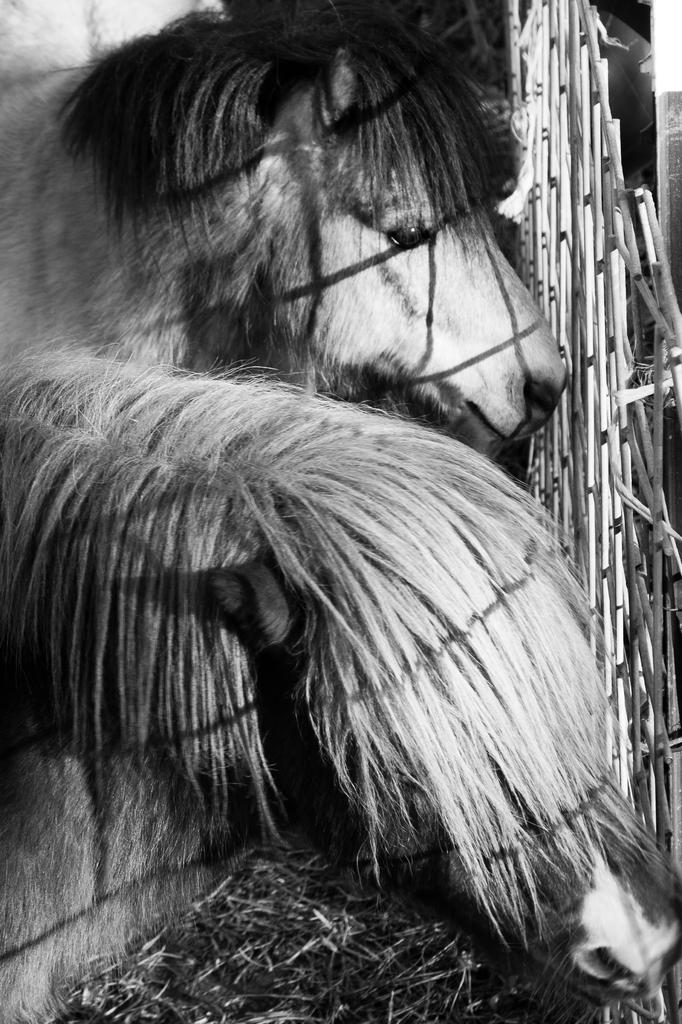What animals are in the center of the image? There are two ponies in the center of the image. What object can be seen on the right side of the image? There is a net on the right side of the image. How many spiders are crawling on the ponies in the image? There are no spiders visible in the image; it features two ponies and a net. What color is the balloon that is tied to the ponies in the image? There is no balloon present in the image; it only shows two ponies and a net. 